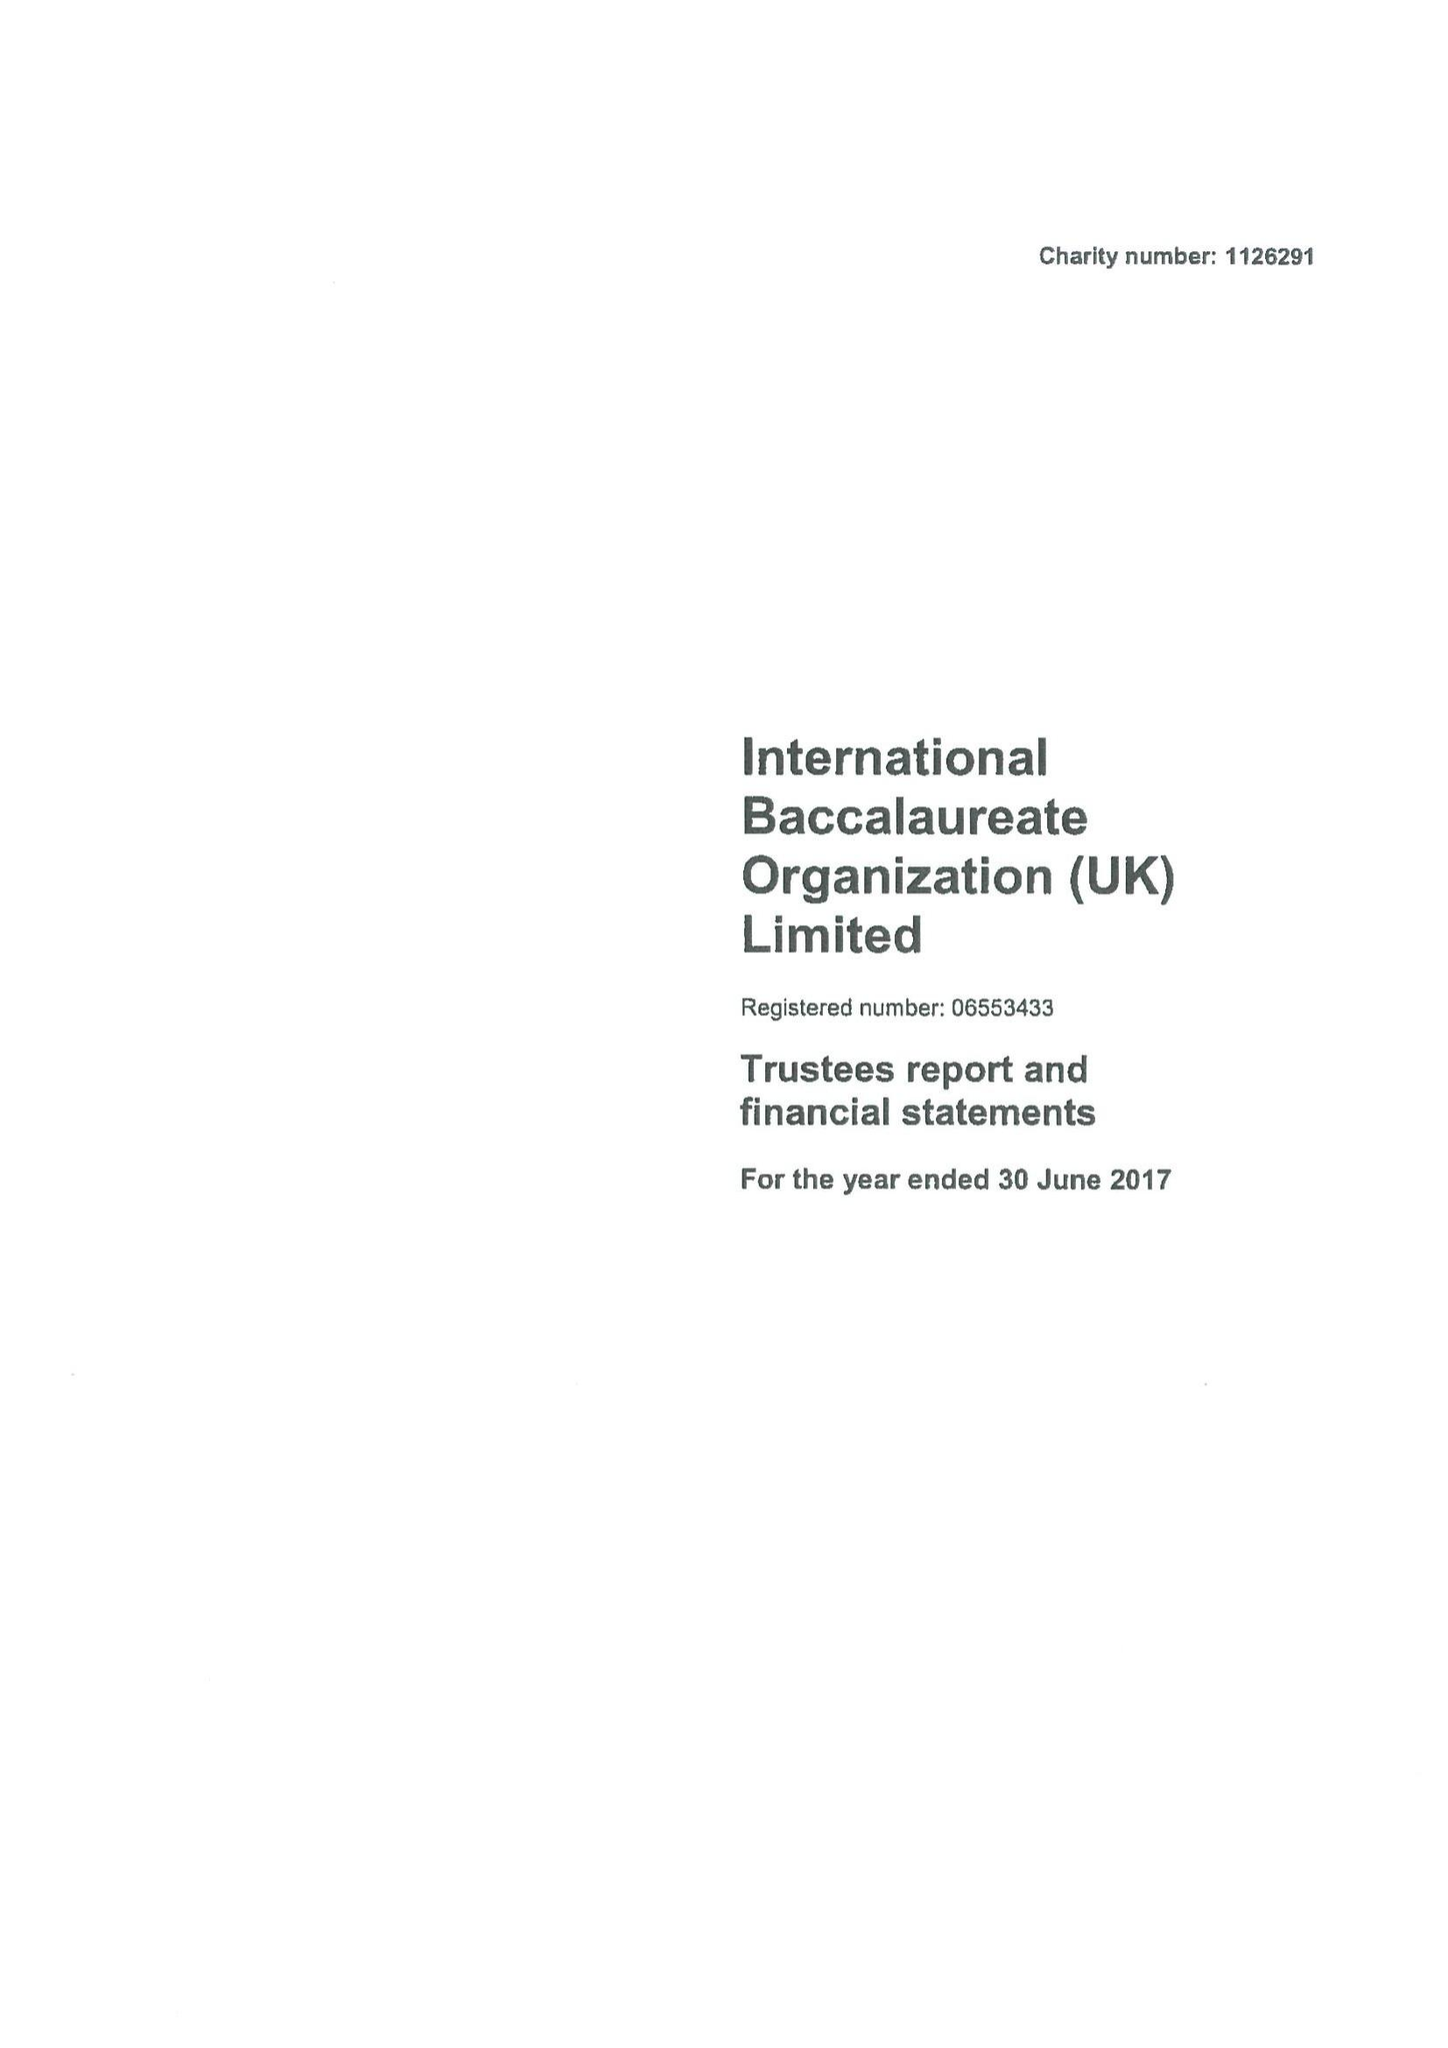What is the value for the spending_annually_in_british_pounds?
Answer the question using a single word or phrase. 17509500.00 